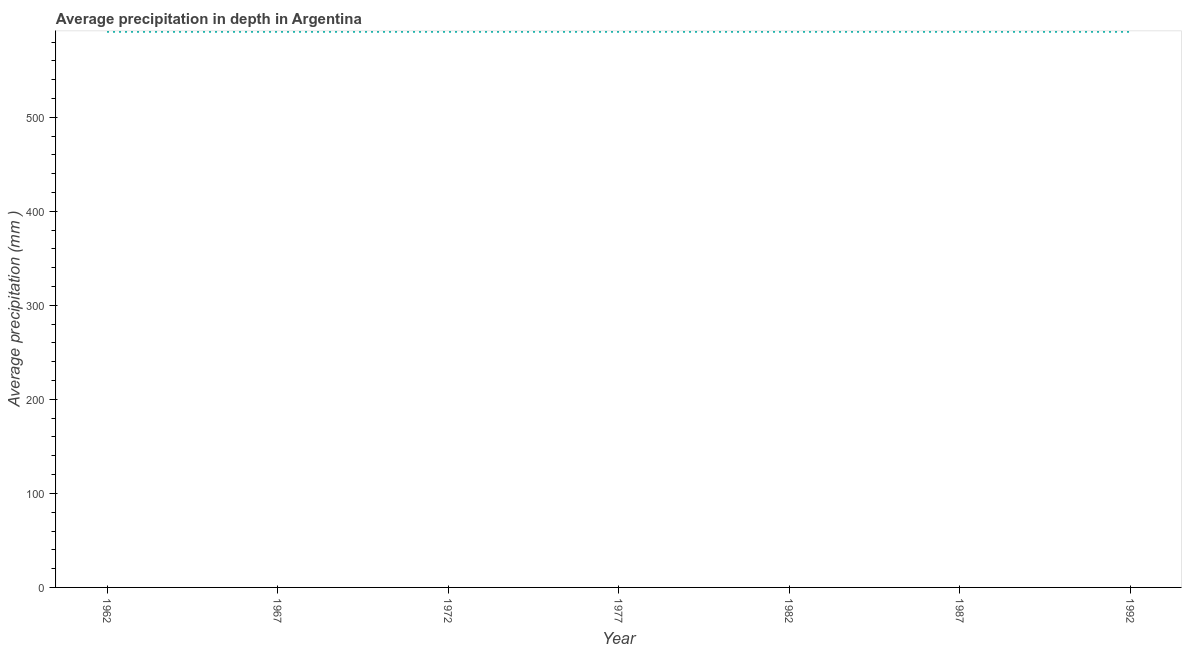What is the average precipitation in depth in 1967?
Offer a very short reply. 591. Across all years, what is the maximum average precipitation in depth?
Keep it short and to the point. 591. Across all years, what is the minimum average precipitation in depth?
Offer a terse response. 591. What is the sum of the average precipitation in depth?
Offer a very short reply. 4137. What is the difference between the average precipitation in depth in 1962 and 1992?
Give a very brief answer. 0. What is the average average precipitation in depth per year?
Your answer should be very brief. 591. What is the median average precipitation in depth?
Your response must be concise. 591. In how many years, is the average precipitation in depth greater than 300 mm?
Provide a short and direct response. 7. Do a majority of the years between 1967 and 1977 (inclusive) have average precipitation in depth greater than 40 mm?
Your answer should be very brief. Yes. What is the ratio of the average precipitation in depth in 1962 to that in 1972?
Make the answer very short. 1. Is the difference between the average precipitation in depth in 1962 and 1987 greater than the difference between any two years?
Keep it short and to the point. Yes. Is the sum of the average precipitation in depth in 1972 and 1987 greater than the maximum average precipitation in depth across all years?
Provide a short and direct response. Yes. Does the average precipitation in depth monotonically increase over the years?
Offer a very short reply. No. How many lines are there?
Your response must be concise. 1. How many years are there in the graph?
Your answer should be compact. 7. Does the graph contain grids?
Give a very brief answer. No. What is the title of the graph?
Your answer should be compact. Average precipitation in depth in Argentina. What is the label or title of the Y-axis?
Give a very brief answer. Average precipitation (mm ). What is the Average precipitation (mm ) in 1962?
Offer a very short reply. 591. What is the Average precipitation (mm ) in 1967?
Offer a terse response. 591. What is the Average precipitation (mm ) in 1972?
Provide a succinct answer. 591. What is the Average precipitation (mm ) of 1977?
Provide a short and direct response. 591. What is the Average precipitation (mm ) in 1982?
Your answer should be compact. 591. What is the Average precipitation (mm ) in 1987?
Make the answer very short. 591. What is the Average precipitation (mm ) of 1992?
Your response must be concise. 591. What is the difference between the Average precipitation (mm ) in 1962 and 1972?
Your response must be concise. 0. What is the difference between the Average precipitation (mm ) in 1962 and 1977?
Offer a terse response. 0. What is the difference between the Average precipitation (mm ) in 1962 and 1982?
Give a very brief answer. 0. What is the difference between the Average precipitation (mm ) in 1962 and 1987?
Keep it short and to the point. 0. What is the difference between the Average precipitation (mm ) in 1967 and 1972?
Keep it short and to the point. 0. What is the difference between the Average precipitation (mm ) in 1967 and 1982?
Your response must be concise. 0. What is the difference between the Average precipitation (mm ) in 1972 and 1977?
Make the answer very short. 0. What is the difference between the Average precipitation (mm ) in 1972 and 1982?
Ensure brevity in your answer.  0. What is the difference between the Average precipitation (mm ) in 1972 and 1987?
Make the answer very short. 0. What is the difference between the Average precipitation (mm ) in 1972 and 1992?
Keep it short and to the point. 0. What is the difference between the Average precipitation (mm ) in 1977 and 1992?
Ensure brevity in your answer.  0. What is the difference between the Average precipitation (mm ) in 1982 and 1987?
Your response must be concise. 0. What is the ratio of the Average precipitation (mm ) in 1962 to that in 1982?
Provide a short and direct response. 1. What is the ratio of the Average precipitation (mm ) in 1962 to that in 1987?
Ensure brevity in your answer.  1. What is the ratio of the Average precipitation (mm ) in 1967 to that in 1982?
Keep it short and to the point. 1. What is the ratio of the Average precipitation (mm ) in 1967 to that in 1987?
Provide a short and direct response. 1. What is the ratio of the Average precipitation (mm ) in 1967 to that in 1992?
Offer a terse response. 1. What is the ratio of the Average precipitation (mm ) in 1972 to that in 1982?
Your answer should be compact. 1. What is the ratio of the Average precipitation (mm ) in 1972 to that in 1987?
Give a very brief answer. 1. What is the ratio of the Average precipitation (mm ) in 1977 to that in 1992?
Keep it short and to the point. 1. What is the ratio of the Average precipitation (mm ) in 1982 to that in 1987?
Your response must be concise. 1. 